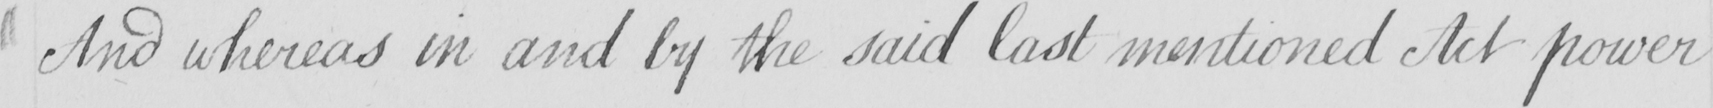What is written in this line of handwriting? And whereas in and by the said last mentioned Act power 